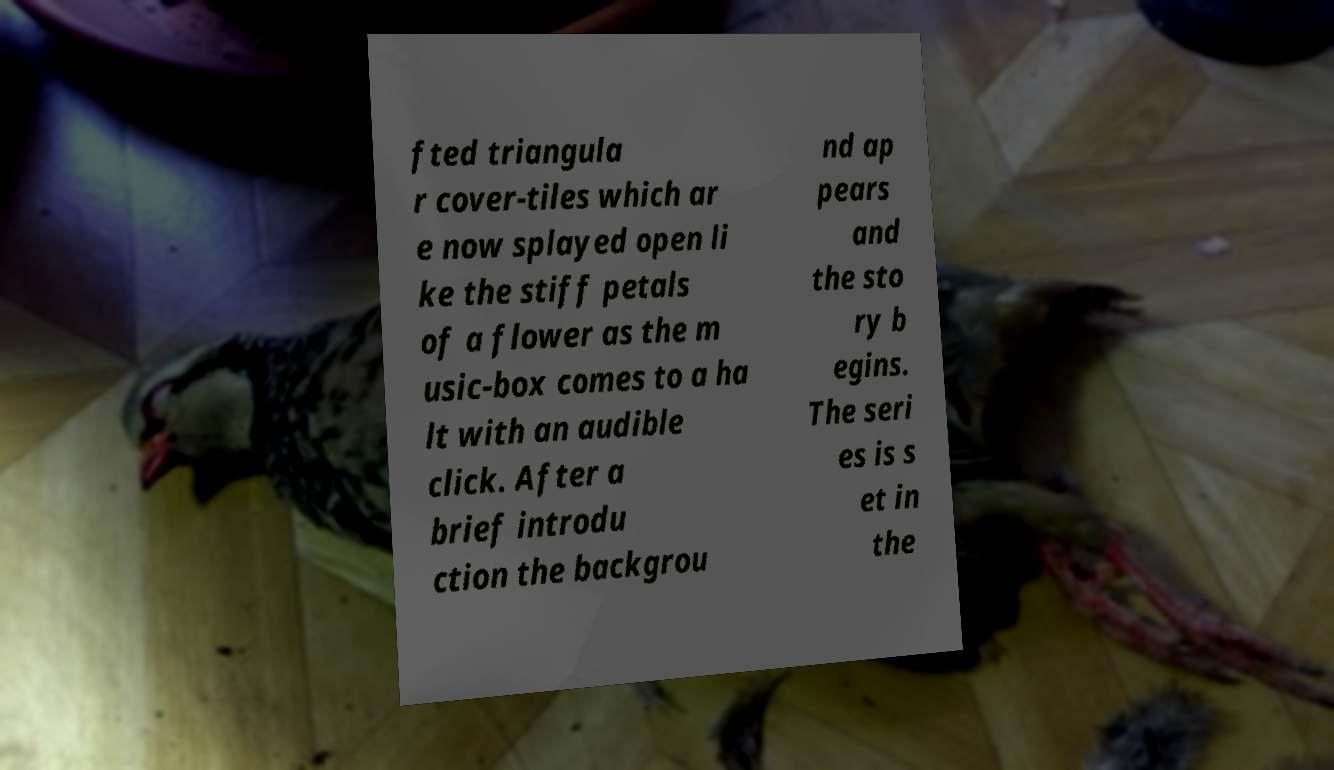Please read and relay the text visible in this image. What does it say? fted triangula r cover-tiles which ar e now splayed open li ke the stiff petals of a flower as the m usic-box comes to a ha lt with an audible click. After a brief introdu ction the backgrou nd ap pears and the sto ry b egins. The seri es is s et in the 